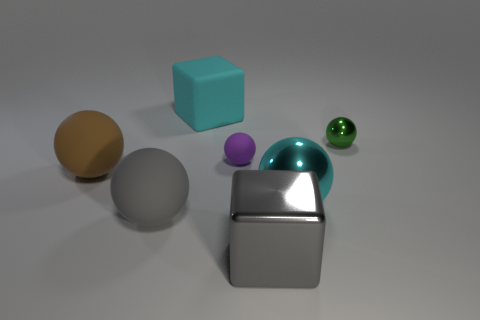Subtract all purple balls. How many balls are left? 4 Subtract all big cyan balls. How many balls are left? 4 Subtract all red spheres. Subtract all red cubes. How many spheres are left? 5 Add 1 brown rubber objects. How many objects exist? 8 Subtract all balls. How many objects are left? 2 Subtract 0 yellow spheres. How many objects are left? 7 Subtract all small objects. Subtract all large yellow matte things. How many objects are left? 5 Add 7 gray shiny cubes. How many gray shiny cubes are left? 8 Add 7 large brown matte things. How many large brown matte things exist? 8 